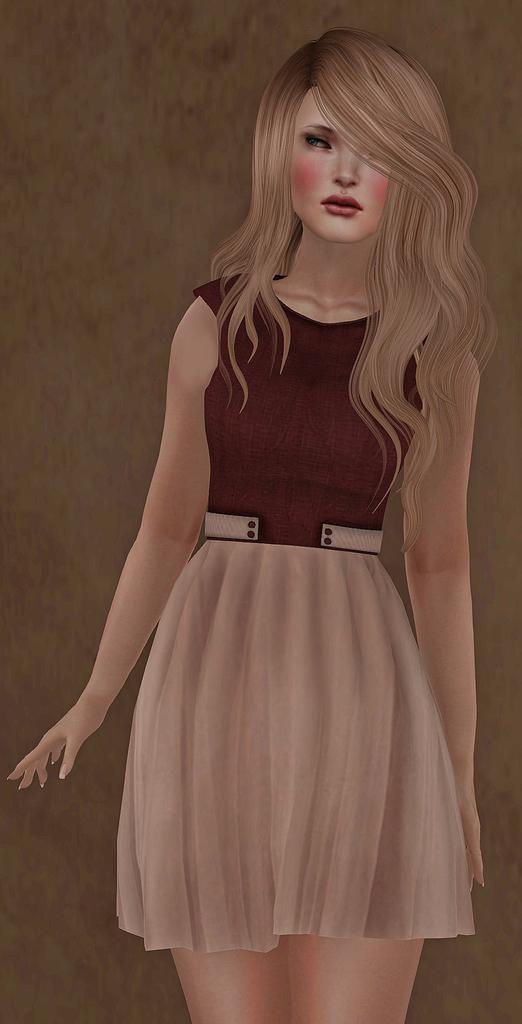What type of image is present in the picture? The image contains an animated picture of a person. How many girls are playing drums in the image? There are no girls or drums present in the image; it contains an animated picture of a person. 